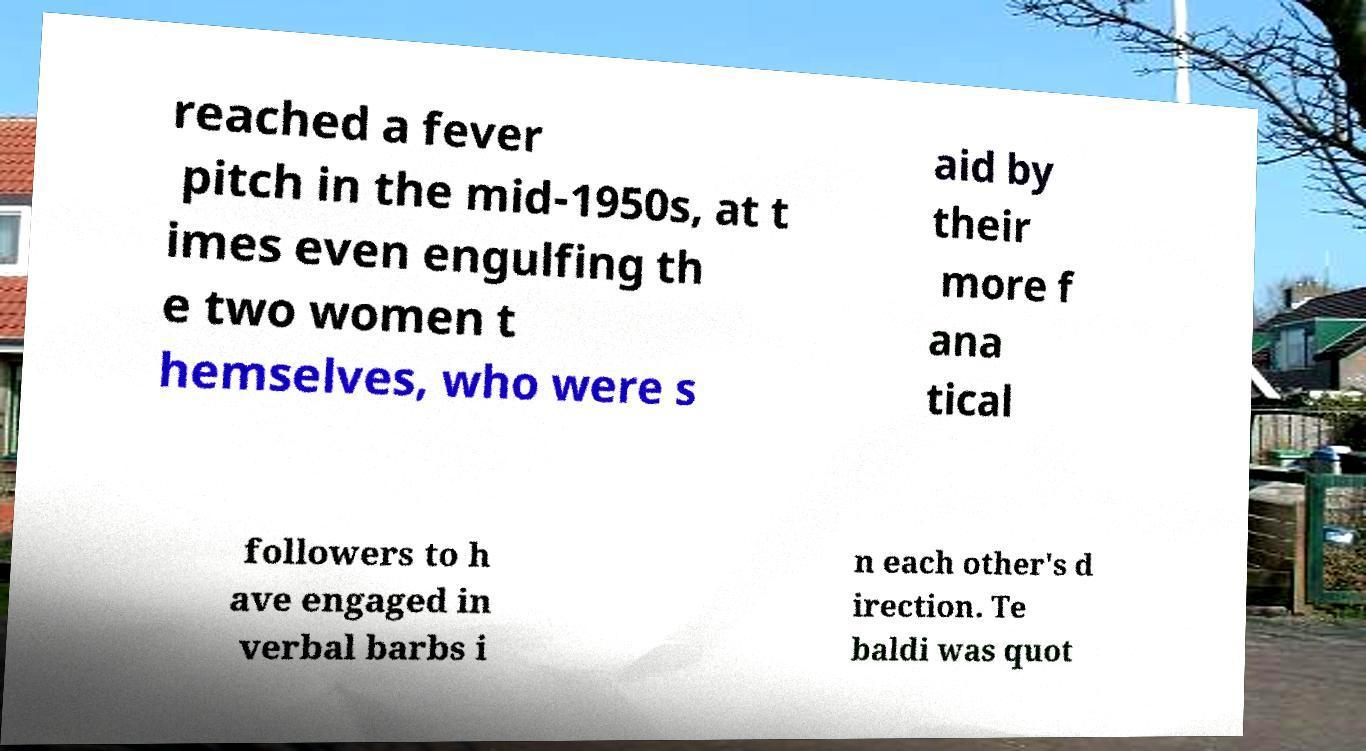Could you extract and type out the text from this image? reached a fever pitch in the mid-1950s, at t imes even engulfing th e two women t hemselves, who were s aid by their more f ana tical followers to h ave engaged in verbal barbs i n each other's d irection. Te baldi was quot 